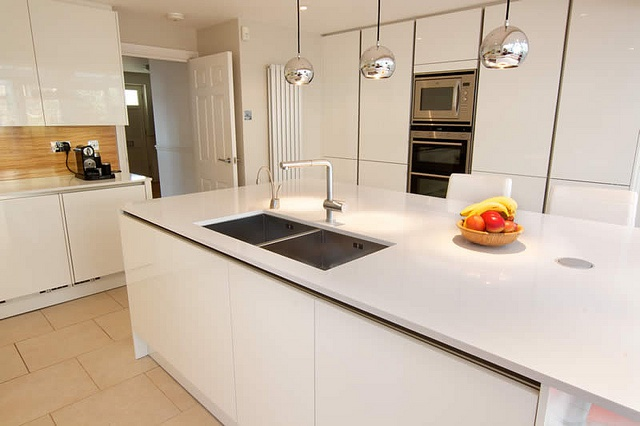Describe the objects in this image and their specific colors. I can see sink in tan, black, and gray tones, oven in tan, black, and gray tones, microwave in tan, gray, maroon, and black tones, chair in lightgray and tan tones, and chair in tan, lightgray, and black tones in this image. 